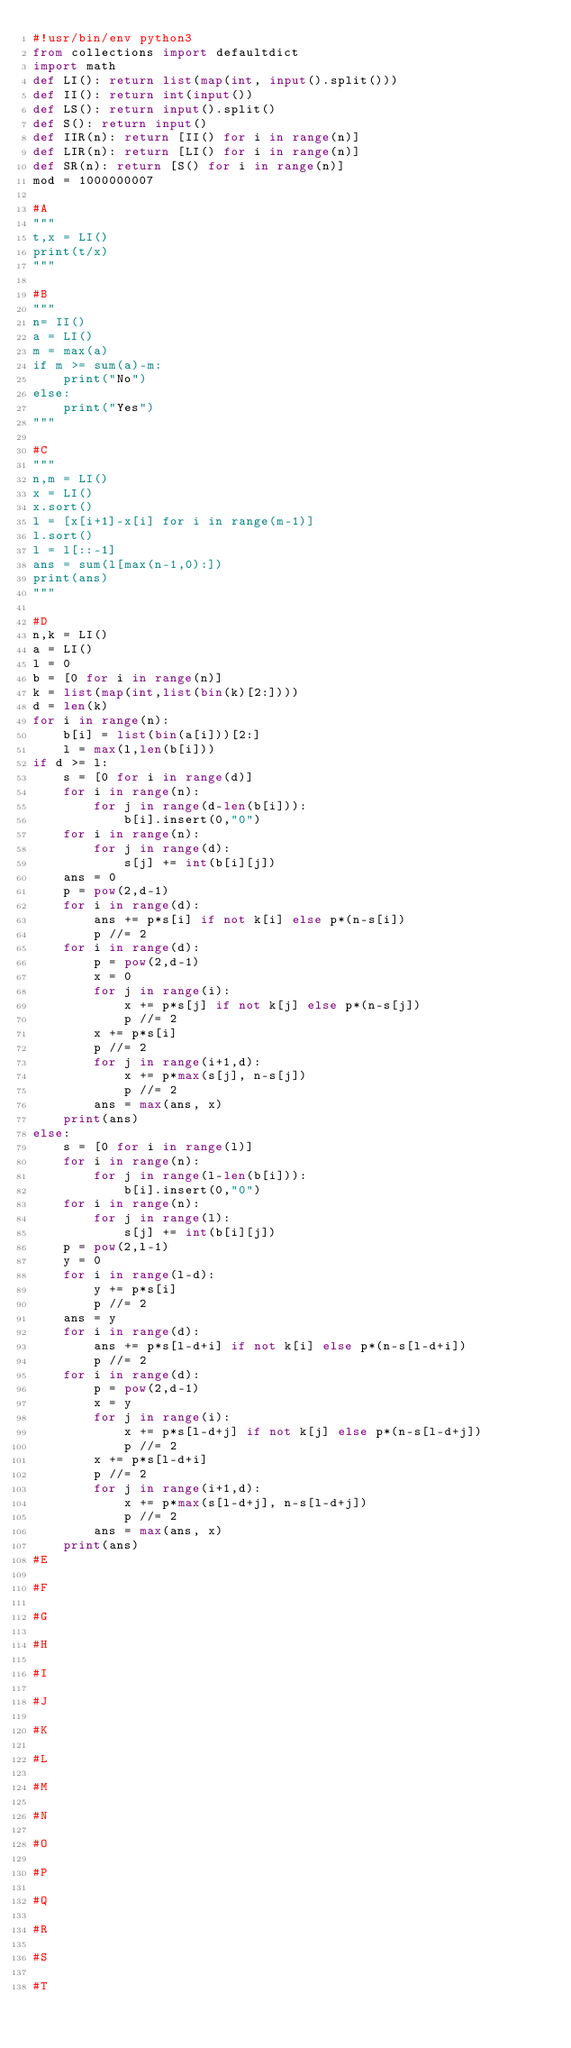Convert code to text. <code><loc_0><loc_0><loc_500><loc_500><_Python_>#!usr/bin/env python3
from collections import defaultdict
import math
def LI(): return list(map(int, input().split()))
def II(): return int(input())
def LS(): return input().split()
def S(): return input()
def IIR(n): return [II() for i in range(n)]
def LIR(n): return [LI() for i in range(n)]
def SR(n): return [S() for i in range(n)]
mod = 1000000007

#A
"""
t,x = LI()
print(t/x)
"""

#B
"""
n= II()
a = LI()
m = max(a)
if m >= sum(a)-m:
    print("No")
else:
    print("Yes")
"""

#C
"""
n,m = LI()
x = LI()
x.sort()
l = [x[i+1]-x[i] for i in range(m-1)]
l.sort()
l = l[::-1]
ans = sum(l[max(n-1,0):])
print(ans)
"""

#D
n,k = LI()
a = LI()
l = 0
b = [0 for i in range(n)]
k = list(map(int,list(bin(k)[2:])))
d = len(k)
for i in range(n):
    b[i] = list(bin(a[i]))[2:]
    l = max(l,len(b[i]))
if d >= l:
    s = [0 for i in range(d)]
    for i in range(n):
        for j in range(d-len(b[i])):
            b[i].insert(0,"0")
    for i in range(n):
        for j in range(d):
            s[j] += int(b[i][j])
    ans = 0
    p = pow(2,d-1)
    for i in range(d):
        ans += p*s[i] if not k[i] else p*(n-s[i])
        p //= 2
    for i in range(d):
        p = pow(2,d-1)
        x = 0
        for j in range(i):
            x += p*s[j] if not k[j] else p*(n-s[j])
            p //= 2
        x += p*s[i]
        p //= 2
        for j in range(i+1,d):
            x += p*max(s[j], n-s[j])
            p //= 2
        ans = max(ans, x)
    print(ans)
else:
    s = [0 for i in range(l)]
    for i in range(n):
        for j in range(l-len(b[i])):
            b[i].insert(0,"0")
    for i in range(n):
        for j in range(l):
            s[j] += int(b[i][j])
    p = pow(2,l-1)
    y = 0
    for i in range(l-d):
        y += p*s[i]
        p //= 2
    ans = y
    for i in range(d):
        ans += p*s[l-d+i] if not k[i] else p*(n-s[l-d+i])
        p //= 2
    for i in range(d):
        p = pow(2,d-1)
        x = y
        for j in range(i):
            x += p*s[l-d+j] if not k[j] else p*(n-s[l-d+j])
            p //= 2
        x += p*s[l-d+i]
        p //= 2
        for j in range(i+1,d):
            x += p*max(s[l-d+j], n-s[l-d+j])
            p //= 2
        ans = max(ans, x)
    print(ans)
#E

#F

#G

#H

#I

#J

#K

#L

#M

#N

#O

#P

#Q

#R

#S

#T
</code> 